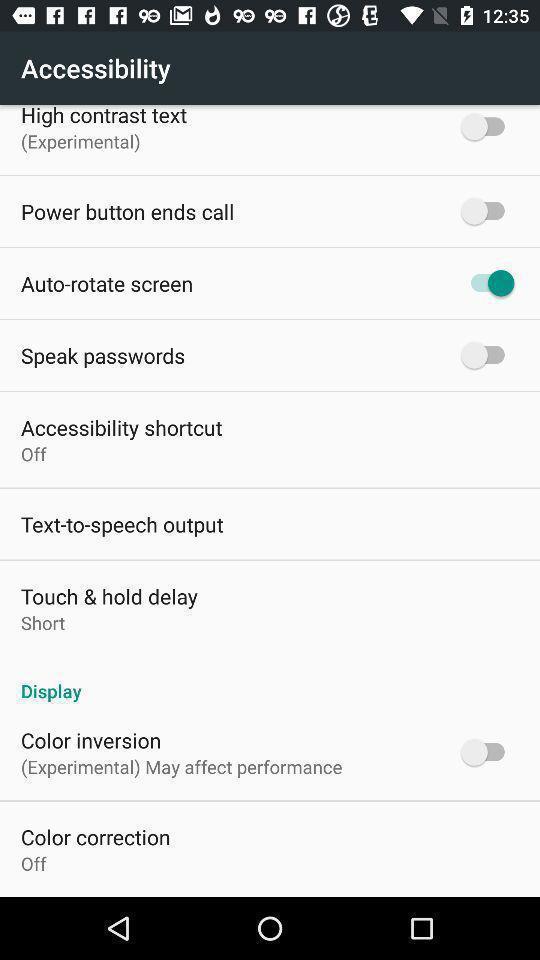Describe the key features of this screenshot. Page displaying list of options for settings. 